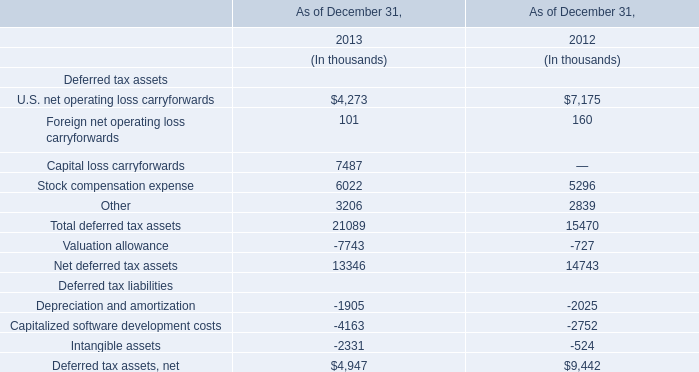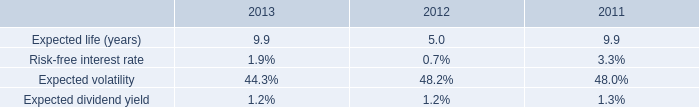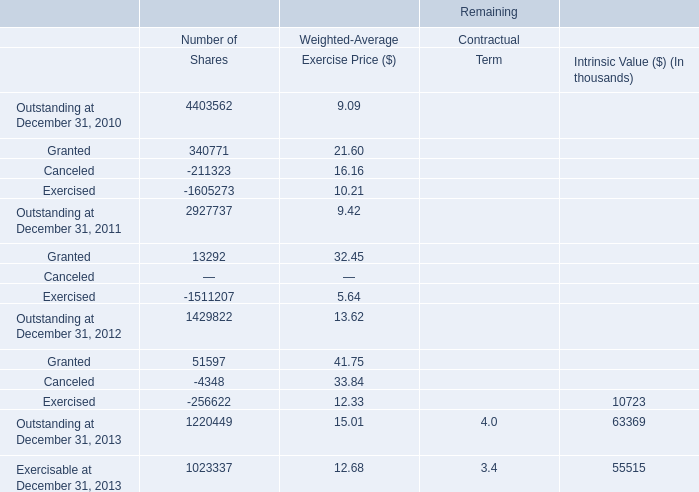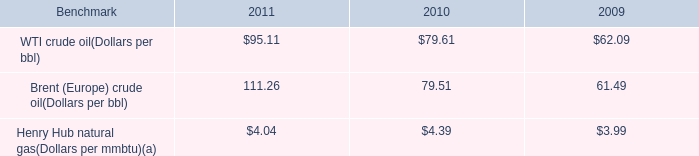What's the total amount of theU.S. net operating loss carryforwards for Deferred tax assets in the years where Expected life (years) is greater than 0? (in thousand) 
Computations: (4273 + 7175)
Answer: 11448.0. 